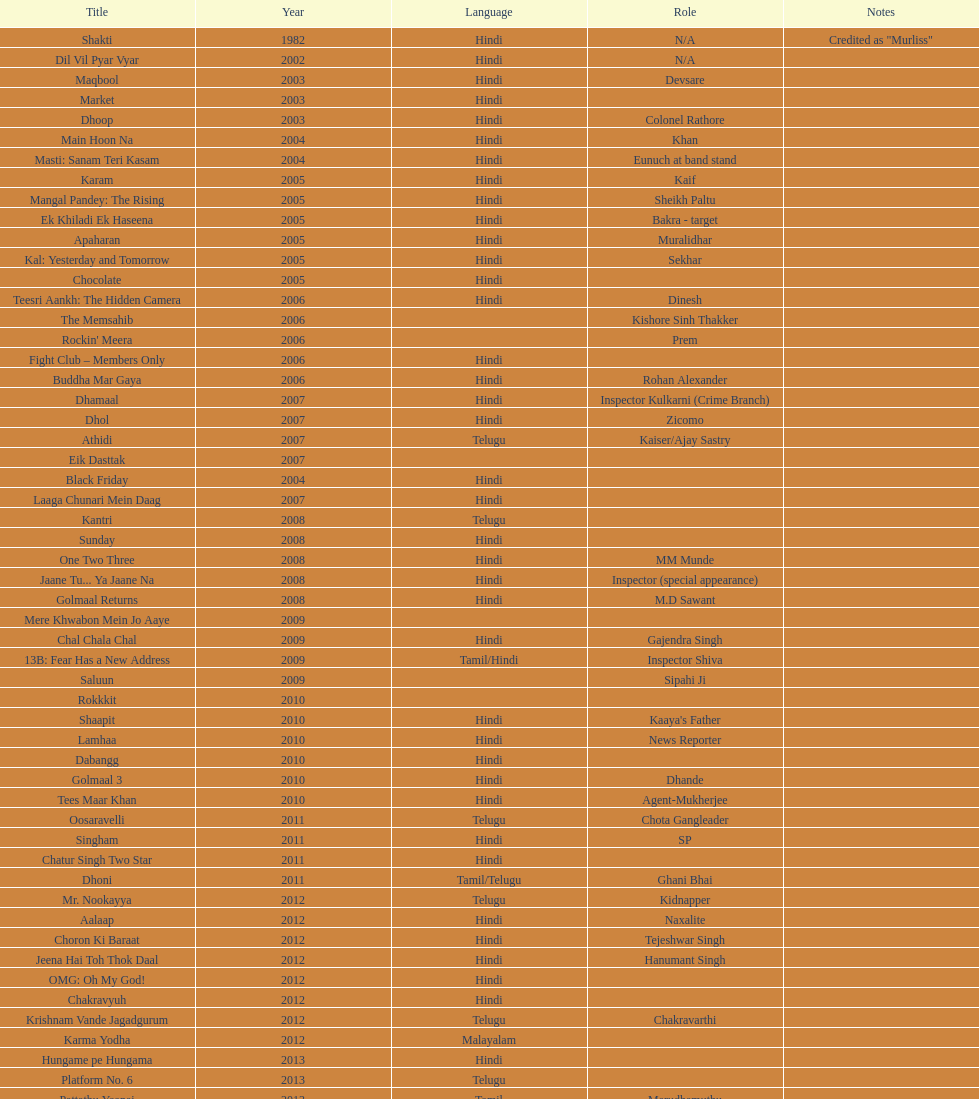What title is before dhol in 2007? Dhamaal. 